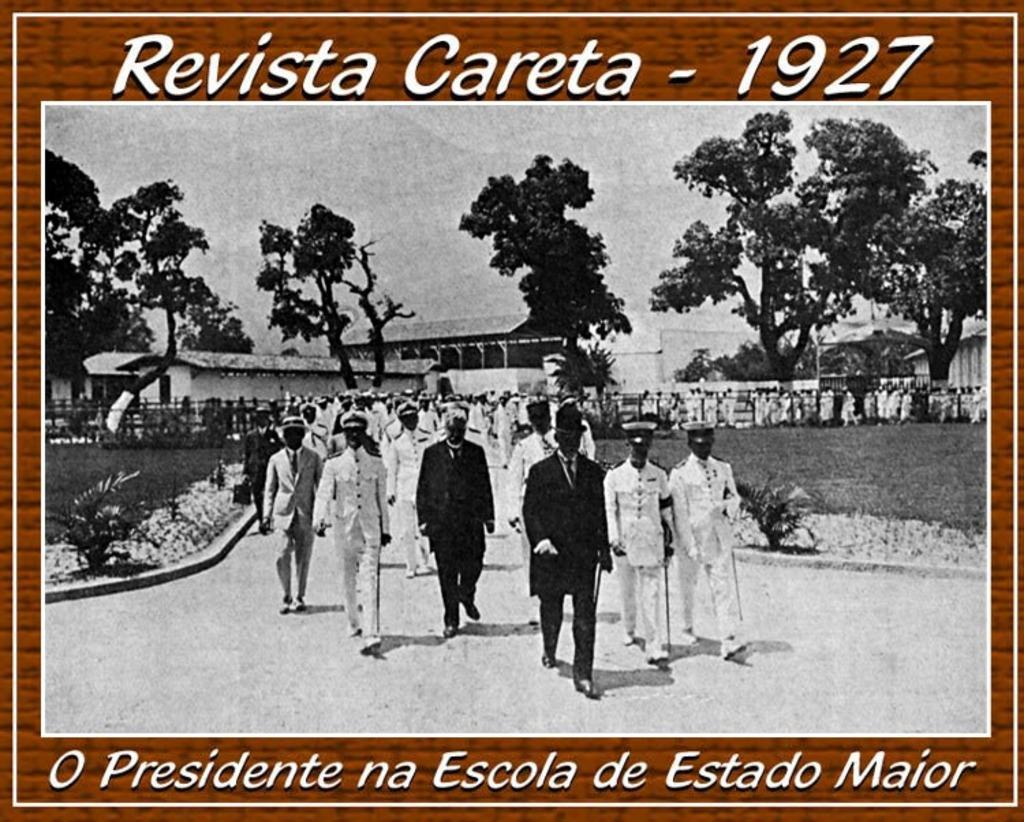<image>
Summarize the visual content of the image. An old postcard from Revista Careta circa 1927. 